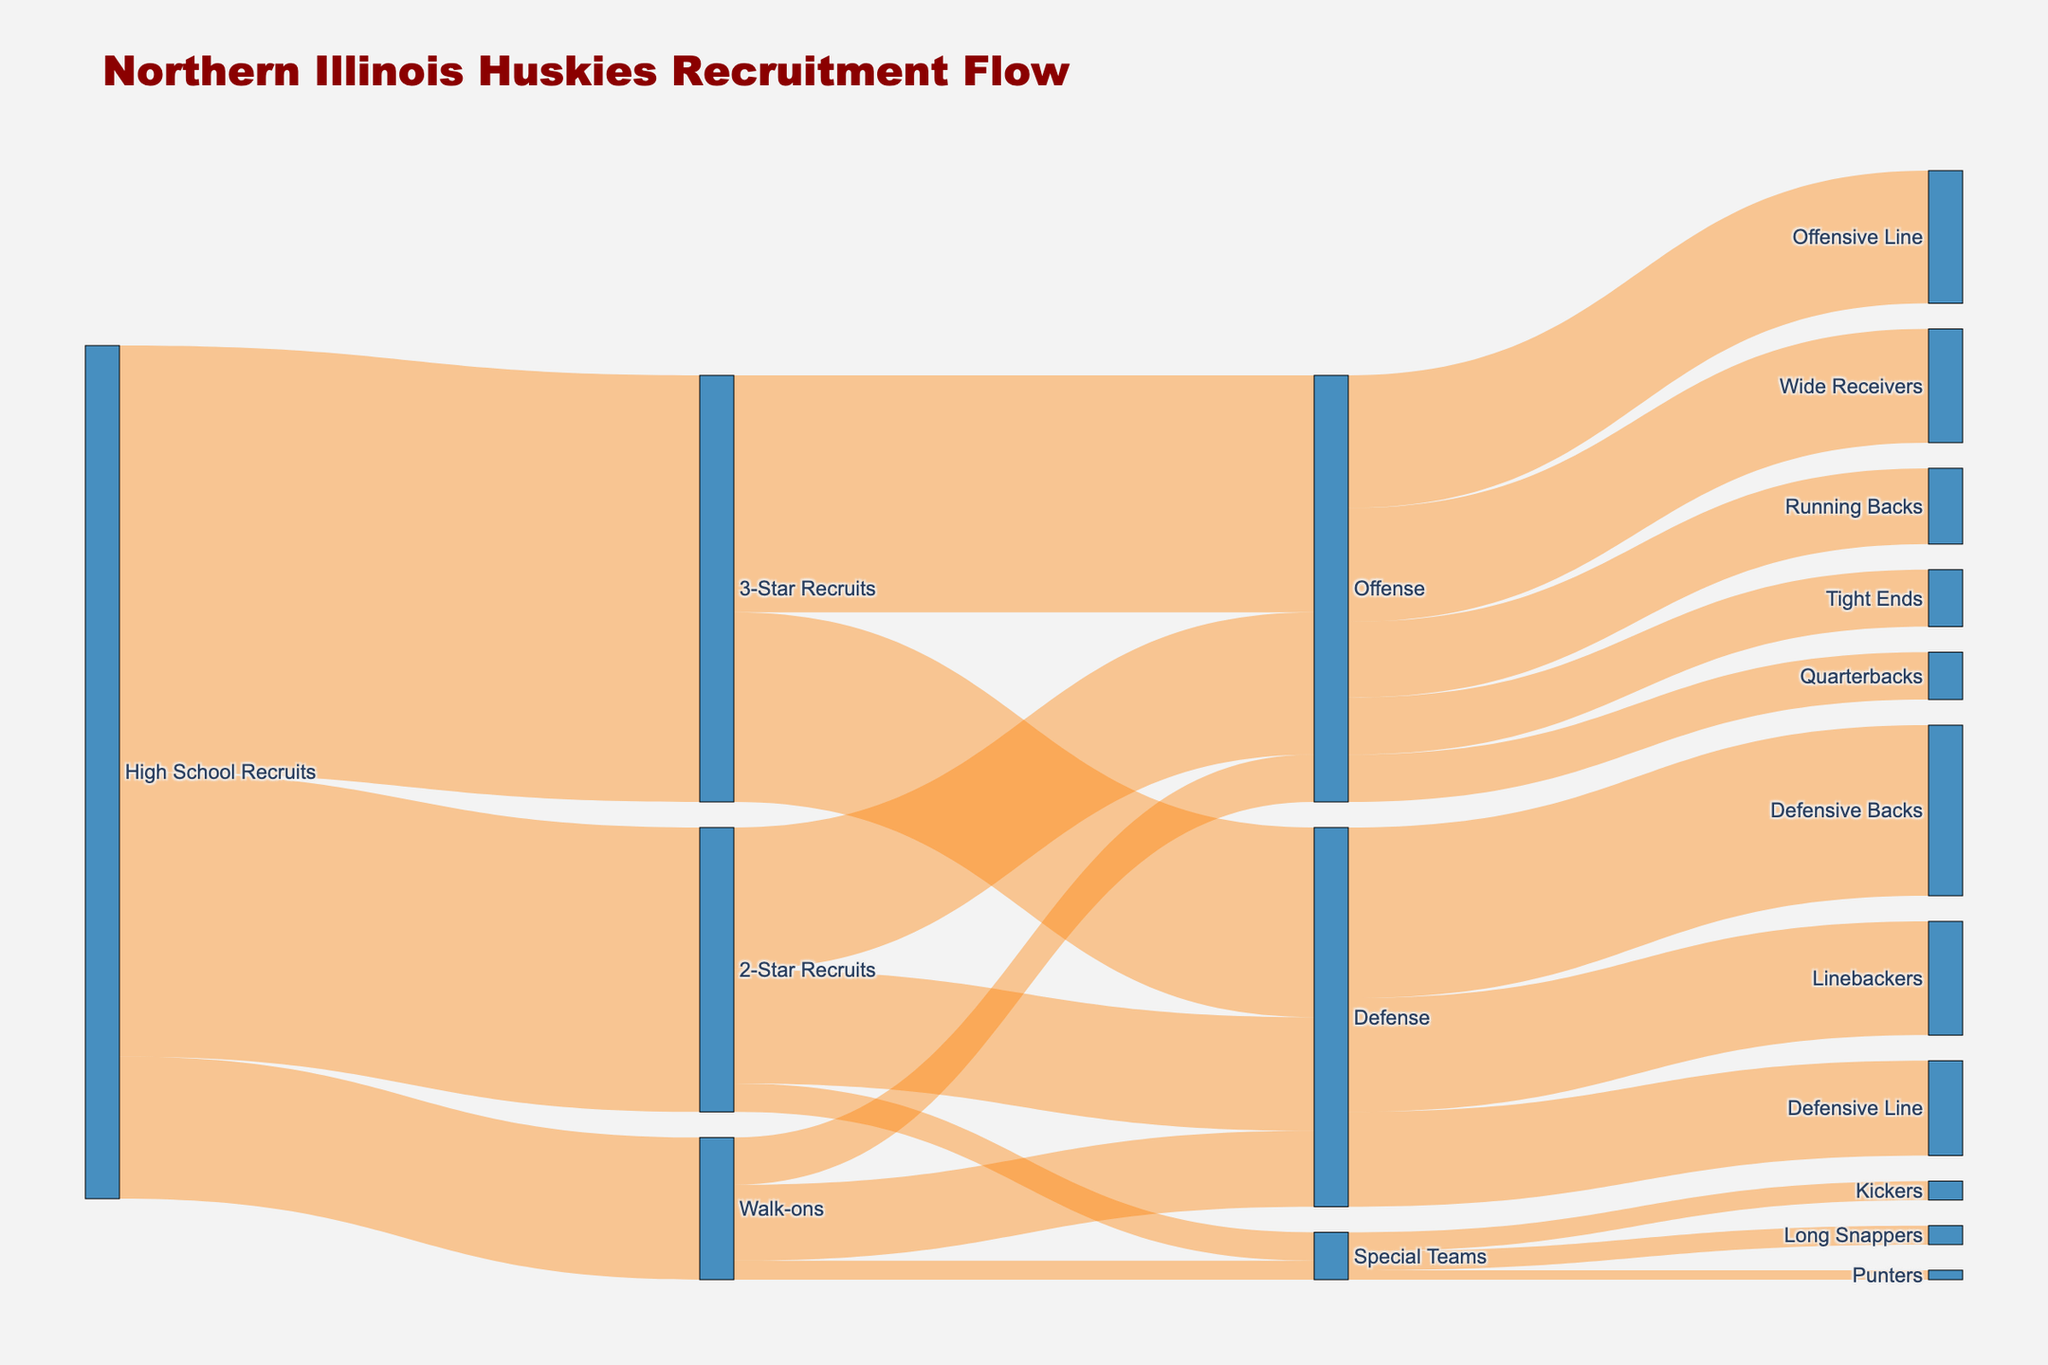what's the title of the diagram? The title of the diagram is the largest and most prominent text at the top. It states "Northern Illinois Huskies Recruitment Flow".
Answer: Northern Illinois Huskies Recruitment Flow how many high school recruits were involved in total? To find the total number of high school recruits, sum the values flowing out from "High School Recruits" which are 45, 30, and 15. Total = 45 + 30 + 15 = 90.
Answer: 90 which group has the highest number of recruits in offense? Look for the group with the highest value flowing into "Offense". The groups that flow into "Offense" are "3-Star Recruits" (25), "2-Star Recruits" (15), and "Walk-ons" (5). The highest value is 25 from "3-Star Recruits".
Answer: 3-Star Recruits how many total recruits are in special teams? Add the values flowing into "Special Teams". The groups that flow into "Special Teams" are "2-Star Recruits" (3) and "Walk-ons" (2). The total is 3 + 2 = 5.
Answer: 5 which specific position has the highest number of recruits? Check the values flowing into each specific position. The positions and their values are: Quarterbacks (5), Running Backs (8), Wide Receivers (12), Tight Ends (6), Offensive Line (14), Defensive Line (10), Linebackers (12), Defensive Backs (18), Kickers (2), Punters (1), and Long Snappers (2). The highest value is 18 for Defensive Backs.
Answer: Defensive Backs compare the number of recruits in wide receivers to tight ends Look at the values flowing into "Wide Receivers" (12) and "Tight Ends" (6). The number of recruits for wide receivers (12) is greater than for tight ends (6).
Answer: Wide Receivers have more recruits what portion of 3-star recruits play defense? The total number of 3-Star Recruits is 45. The number of these recruits playing defense is 20. The portion is 20/45 = 4/9 or roughly 44.4%.
Answer: 44.4% how are the 2-star recruits distributed among the three areas? Look at the flow from "2-Star Recruits" to "Offense" (15), "Defense" (12), and "Special Teams" (3). The values are distributed as follows: offense (15), defense (12), and special teams (3).
Answer: Offense: 15, Defense: 12, Special Teams: 3 how many more recruits are in the offensive line compared to tight ends? The number of recruits in the offensive line is 14 and in tight ends is 6. The difference is 14 - 6 = 8.
Answer: 8 